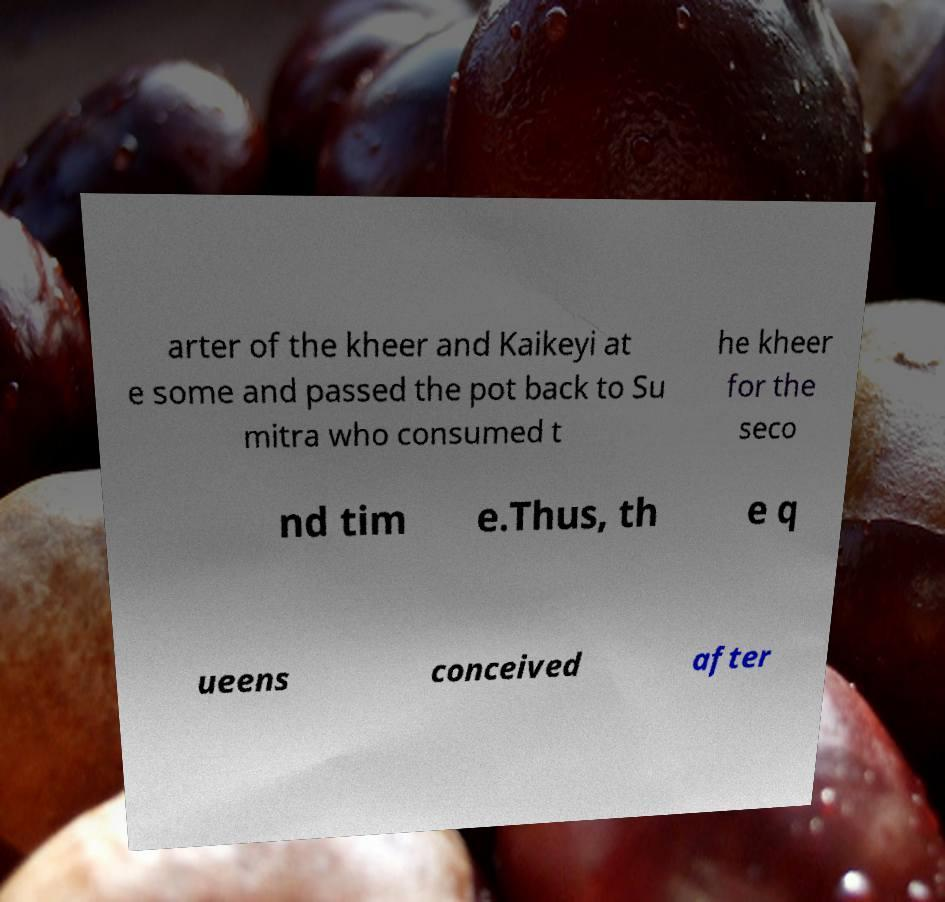For documentation purposes, I need the text within this image transcribed. Could you provide that? arter of the kheer and Kaikeyi at e some and passed the pot back to Su mitra who consumed t he kheer for the seco nd tim e.Thus, th e q ueens conceived after 